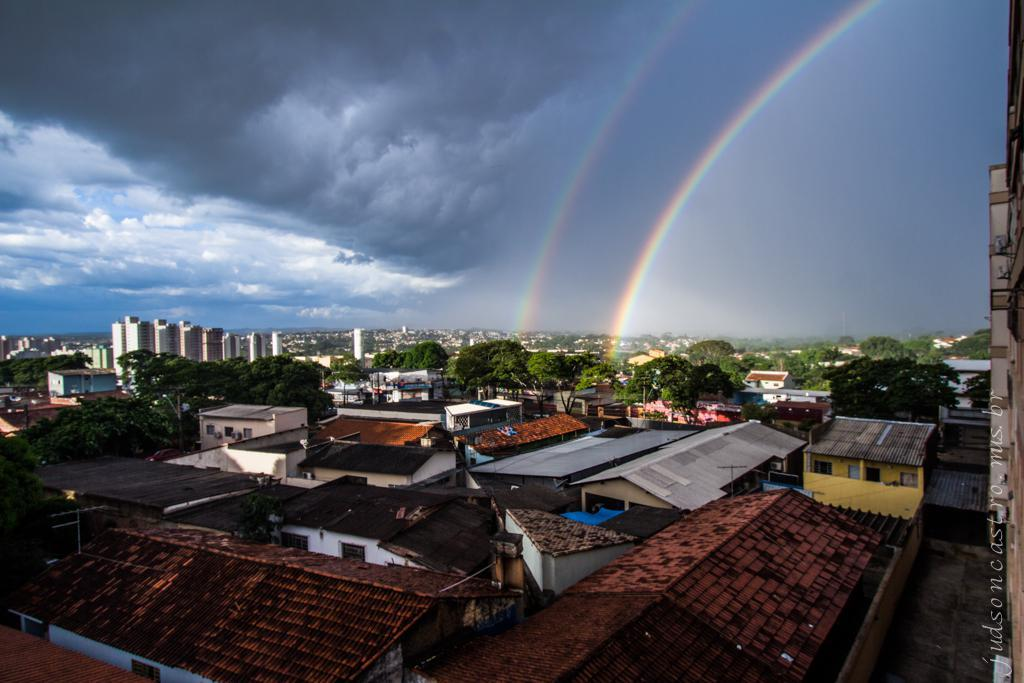What type of structures can be seen in the image? There are houses, buildings, and trees in the image. What natural phenomenon is visible in the image? There is a rainbow in the image. What part of the natural environment is visible in the image? The sky is visible in the image, along with clouds. What type of dress is the library wearing in the image? There is no library or dress present in the image. 